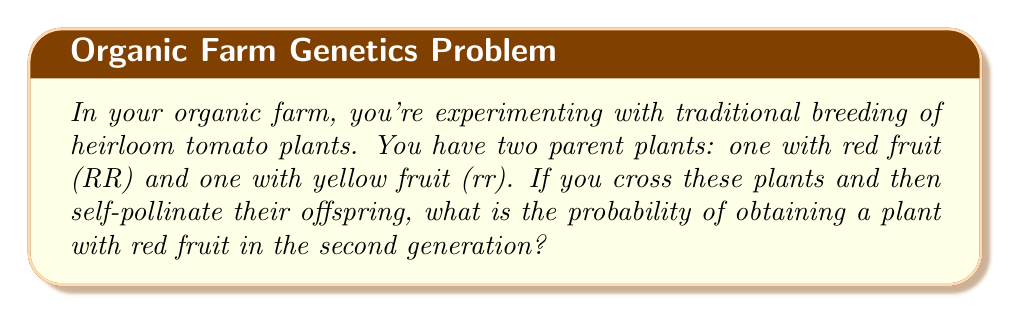What is the answer to this math problem? Let's approach this step-by-step:

1) First, let's understand the genetic notation:
   R = dominant allele for red fruit
   r = recessive allele for yellow fruit

2) The parent plants are:
   RR (red fruit) and rr (yellow fruit)

3) When we cross these parents, all offspring in the first generation (F1) will be Rr:

   $$RR \times rr \rightarrow Rr$$

4) All F1 plants will have red fruit due to the dominance of R.

5) Now, when we self-pollinate the F1 plants (Rr × Rr), we can use a Punnett square:

   $$\begin{array}{c|cc}
     & R & r \\
   \hline
   R & RR & Rr \\
   r & Rr & rr
   \end{array}$$

6) From this, we can see the possible genotypes in F2:
   RR (red fruit): 1/4
   Rr (red fruit): 2/4 = 1/2
   rr (yellow fruit): 1/4

7) The probability of obtaining a plant with red fruit is the sum of probabilities of RR and Rr:

   $$P(\text{red fruit}) = P(RR) + P(Rr) = \frac{1}{4} + \frac{1}{2} = \frac{3}{4}$$
Answer: $\frac{3}{4}$ or 0.75 or 75% 